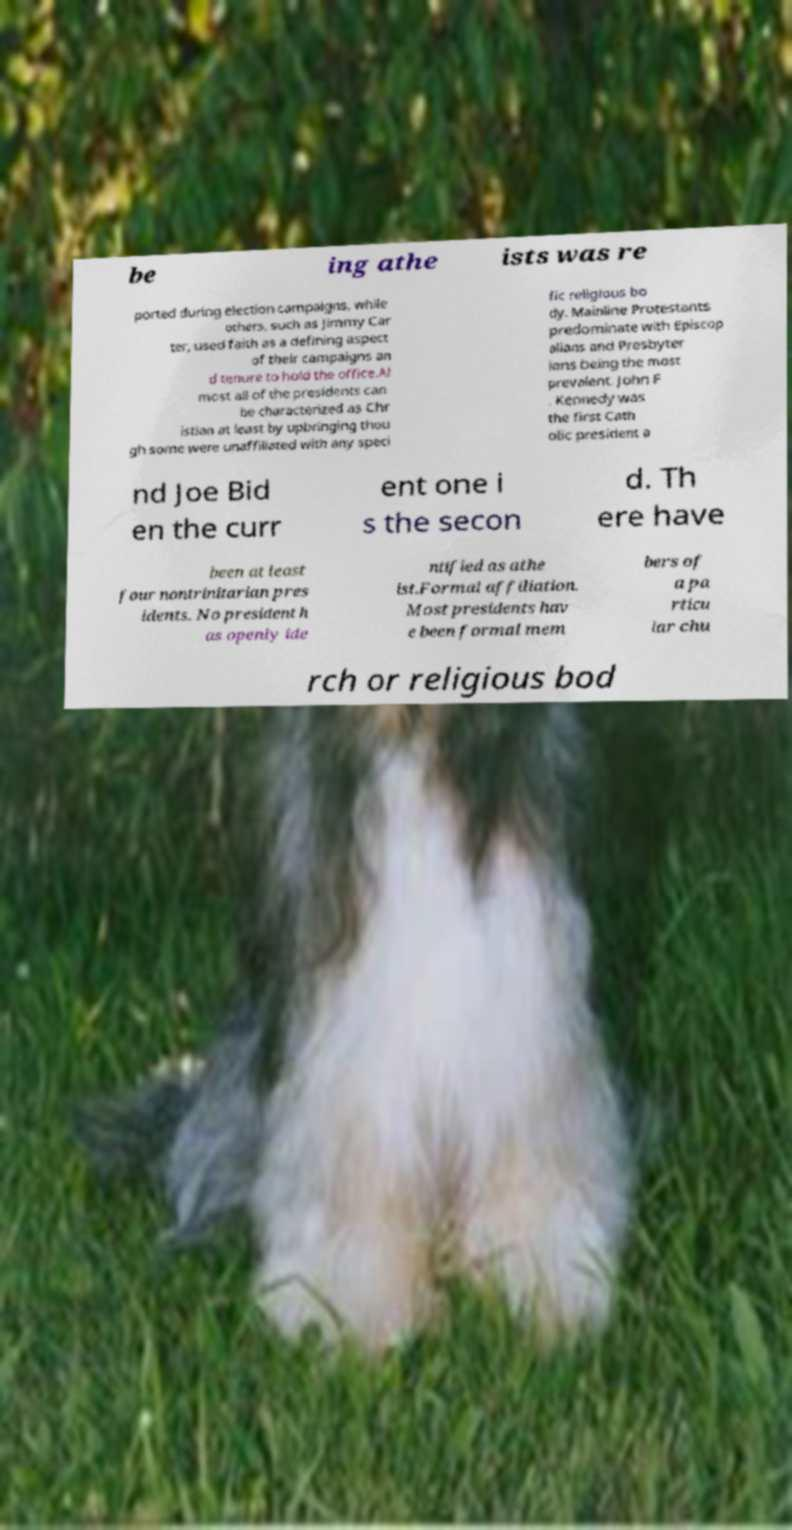Can you read and provide the text displayed in the image?This photo seems to have some interesting text. Can you extract and type it out for me? be ing athe ists was re ported during election campaigns, while others, such as Jimmy Car ter, used faith as a defining aspect of their campaigns an d tenure to hold the office.Al most all of the presidents can be characterized as Chr istian at least by upbringing thou gh some were unaffiliated with any speci fic religious bo dy. Mainline Protestants predominate with Episcop alians and Presbyter ians being the most prevalent. John F . Kennedy was the first Cath olic president a nd Joe Bid en the curr ent one i s the secon d. Th ere have been at least four nontrinitarian pres idents. No president h as openly ide ntified as athe ist.Formal affiliation. Most presidents hav e been formal mem bers of a pa rticu lar chu rch or religious bod 